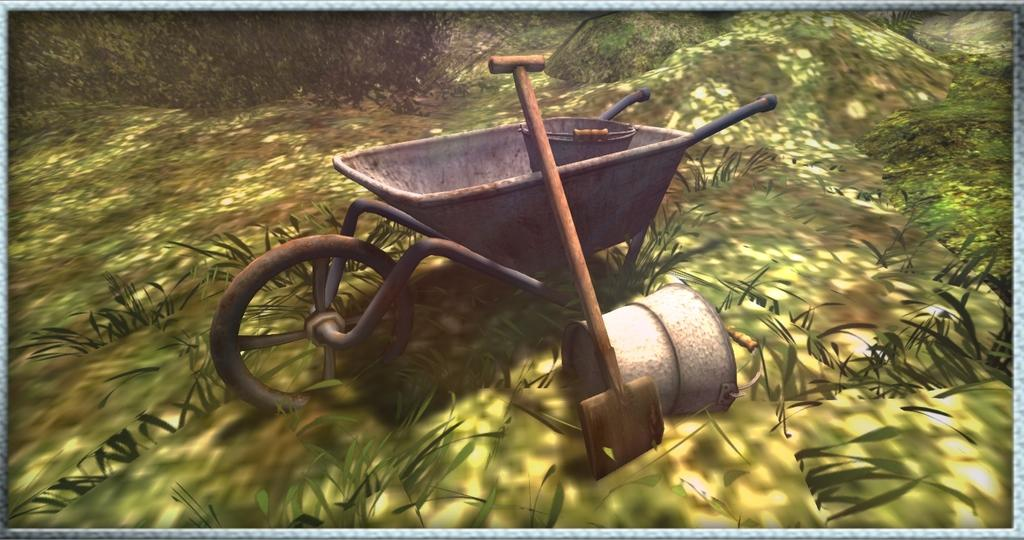What type of image is being described? The image is an animation. What object can be seen in the animation? There is a wheelbarrow in the image. What is inside the wheelbarrow? There is a bucket in the wheelbarrow. What other object is present in the image? There is a spade in the image. Are there any other buckets in the image? Yes, there is a second bucket in the image. What is the ground surface like in the animation? There is grass on the ground in the image. How does the grass react to the spade in the image? The grass does not react to the spade in the image, as it is an inanimate object. 